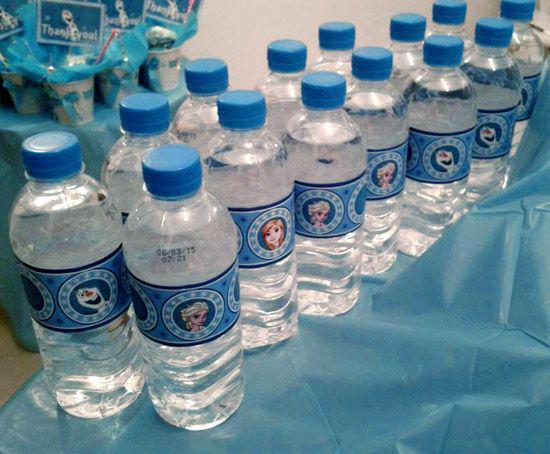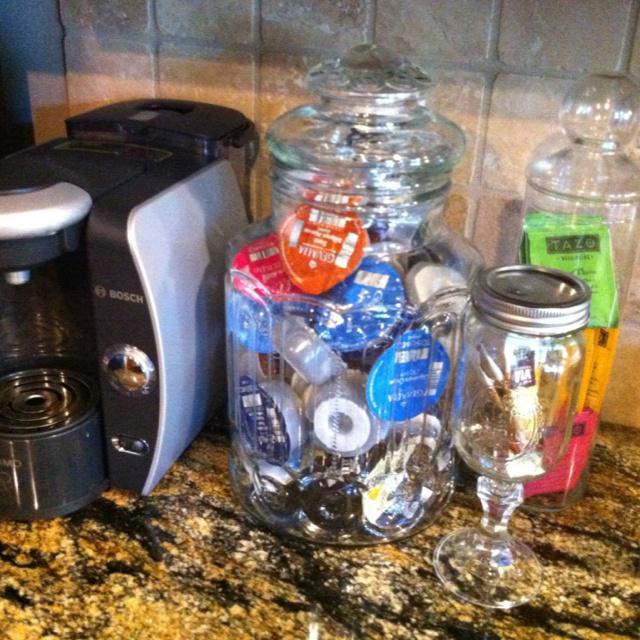The first image is the image on the left, the second image is the image on the right. For the images shown, is this caption "At least 12 water bottles are visible in one or more images." true? Answer yes or no. Yes. 